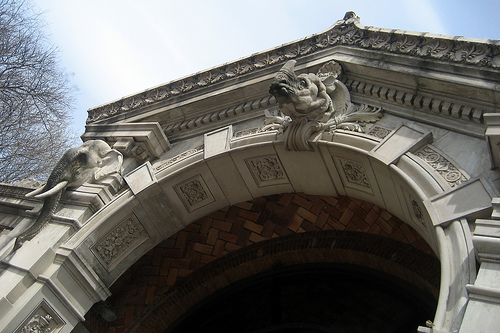<image>
Can you confirm if the elephant is on the pillar? Yes. Looking at the image, I can see the elephant is positioned on top of the pillar, with the pillar providing support. Where is the elephant in relation to the tree? Is it under the tree? Yes. The elephant is positioned underneath the tree, with the tree above it in the vertical space. 